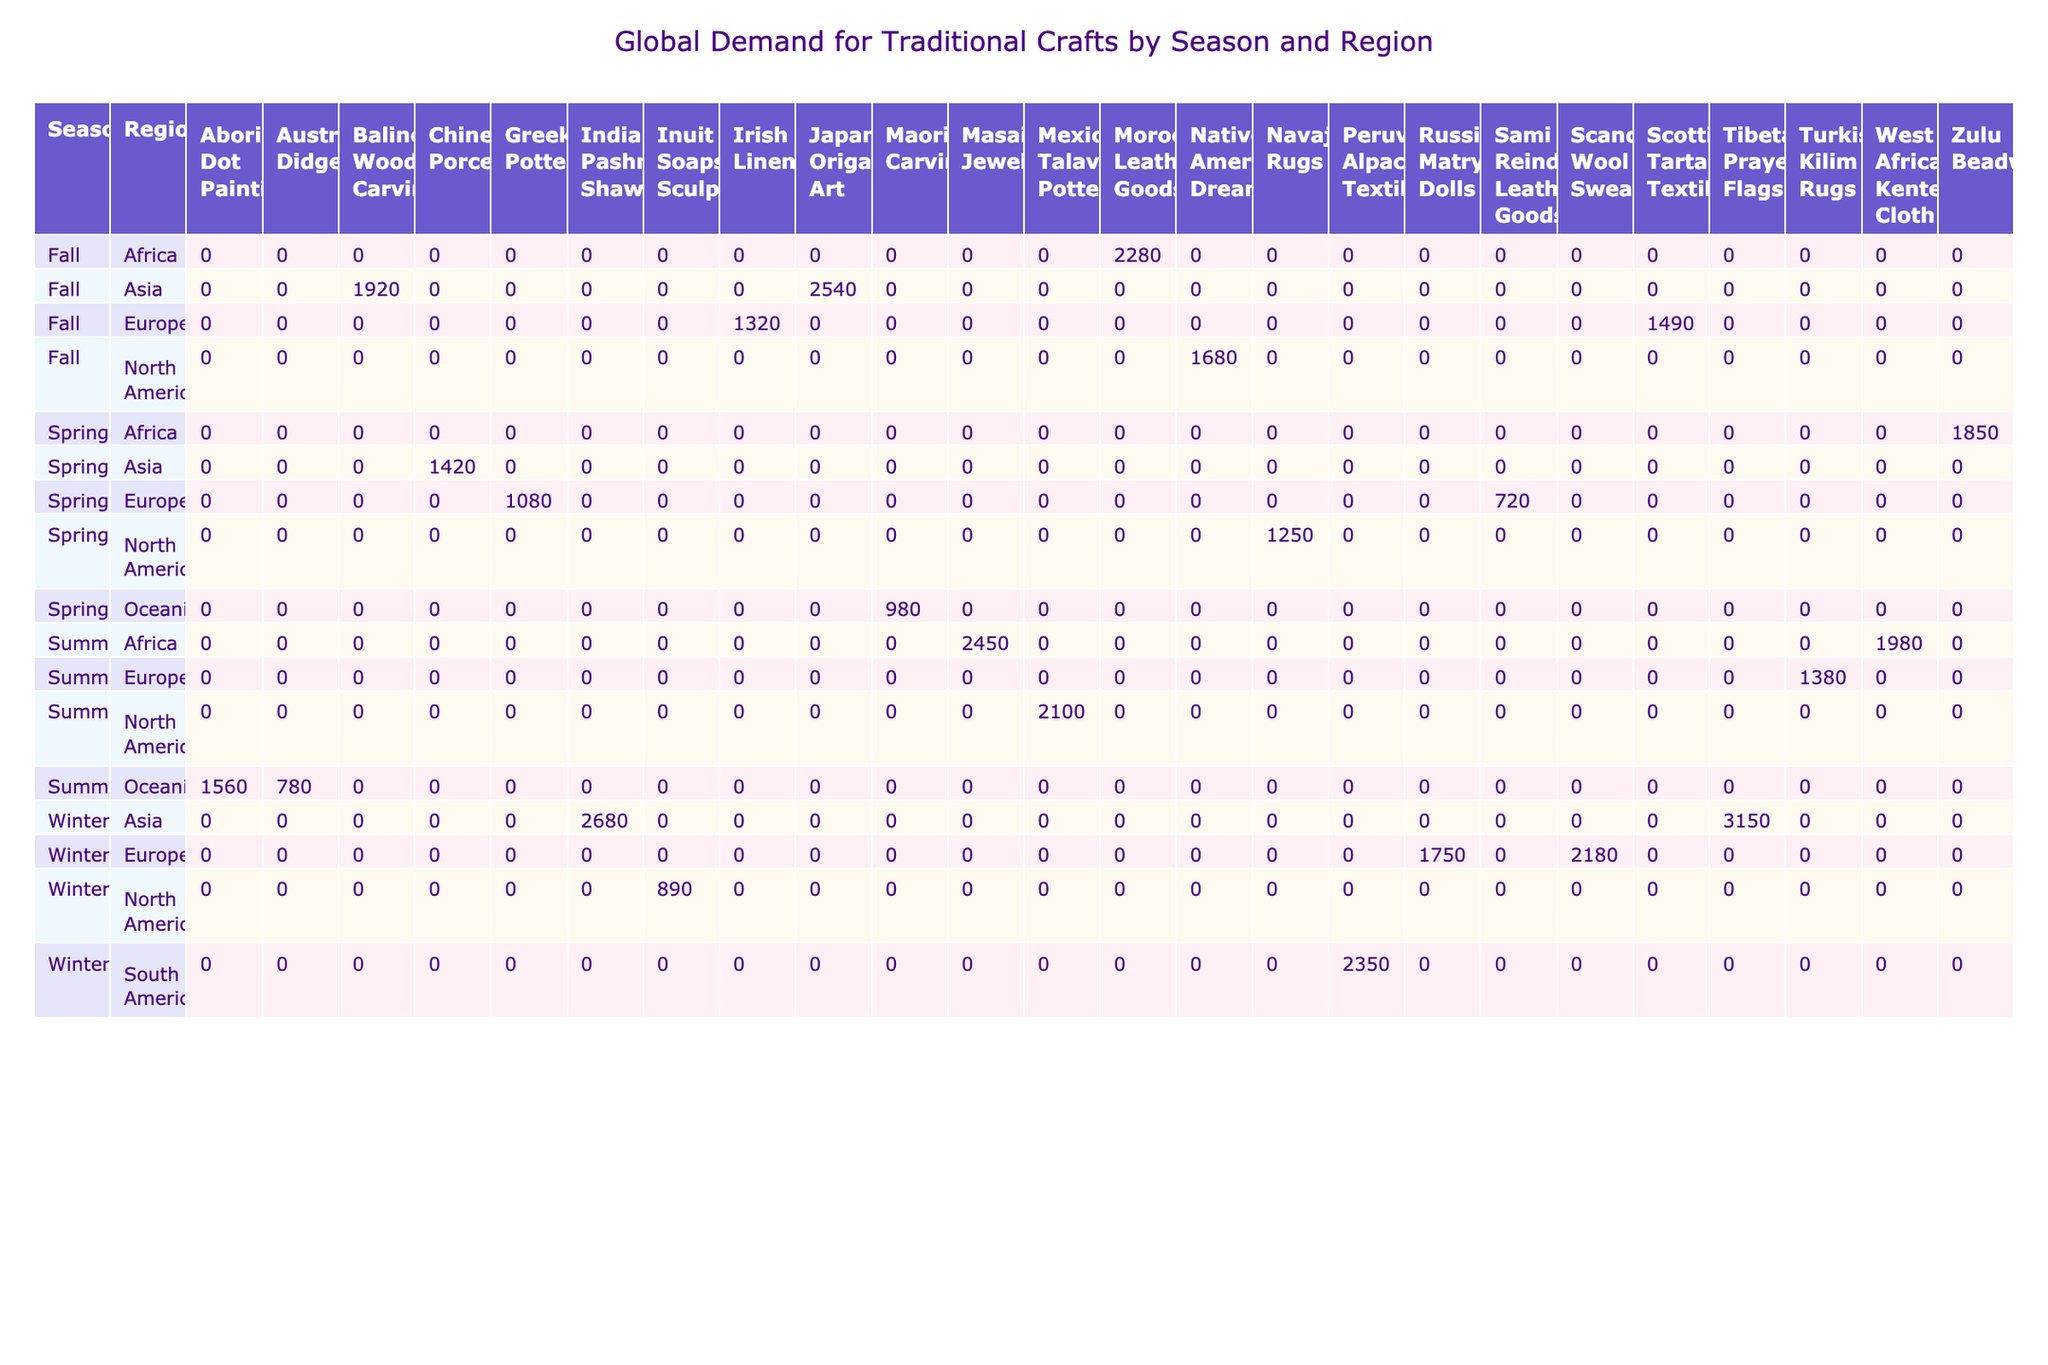What is the highest sales volume for any craft type in Summer? The table reflects that the highest sales volume for any craft type in Summer is from Masai Jewelry, with a total of 2450 units sold in Africa.
Answer: 2450 Which craft type had the lowest sales volume in Fall? The craft type with the lowest sales volume in Fall is Japanese Origami Art, with 2540 units sold in Asia.
Answer: 2540 Is the average price of Tibetan Prayer Flags lower than that of Zulu Beadwork? Yes, the average price of Tibetan Prayer Flags is 45 USD, while Zulu Beadwork is 180 USD, making Tibetan Prayer Flags cheaper.
Answer: Yes How much higher is the sales volume of Indian Pashmina Shawls compared to Inuit Soapstone Sculptures in Winter? The sales volume of Indian Pashmina Shawls is 2680 and for Inuit Soapstone Sculptures, it is 890. The difference is calculated as 2680 - 890 = 1790.
Answer: 1790 In which season does Maori Carvings have the highest sales volume? Maori Carvings only appear in the Spring season, with a total sales volume of 980. Therefore, Spring is the season where they have the highest sales volume.
Answer: Spring Which region had the highest total sales volume across all seasons? To find this, we sum the sales volumes for North America, Oceania, Europe, Africa, Asia, and South America. North America totals to 1250 + 2100 + 1680 + 890 = 4920; Oceania totals to 980 + 1560 + 780 = 3320; Europe totals to 720 + 1380 + 1490 + 1750 + 2180 = 10120; Africa totals to 1850 + 2450 + 2280 = 6580; Asia totals to 2540 + 1320 + 3150 = 7010; and South America totals to 2350. Thus, Europe has the highest total sales volume of 10120.
Answer: Europe Are there more craft types listed in Fall than in Spring? In the table, there are four craft types listed for Fall: Native American Dreamcatchers, Balinese Wood Carvings, Scottish Tartan Textiles, and Moroccan Leather Goods. For Spring, there are also four craft types: Navajo Rugs, Maori Carvings, Sami Reindeer Leather Goods, and Zulu Beadwork. Thus, they have an equal number of craft types.
Answer: No What is the total sales volume for Turkish Kilim Rugs and Scandinavian Wool Sweaters combined? The total sales volume for Turkish Kilim Rugs is 1380 and for Scandinavian Wool Sweaters it is 2180. The combined total is 1380 + 2180 = 3560.
Answer: 3560 